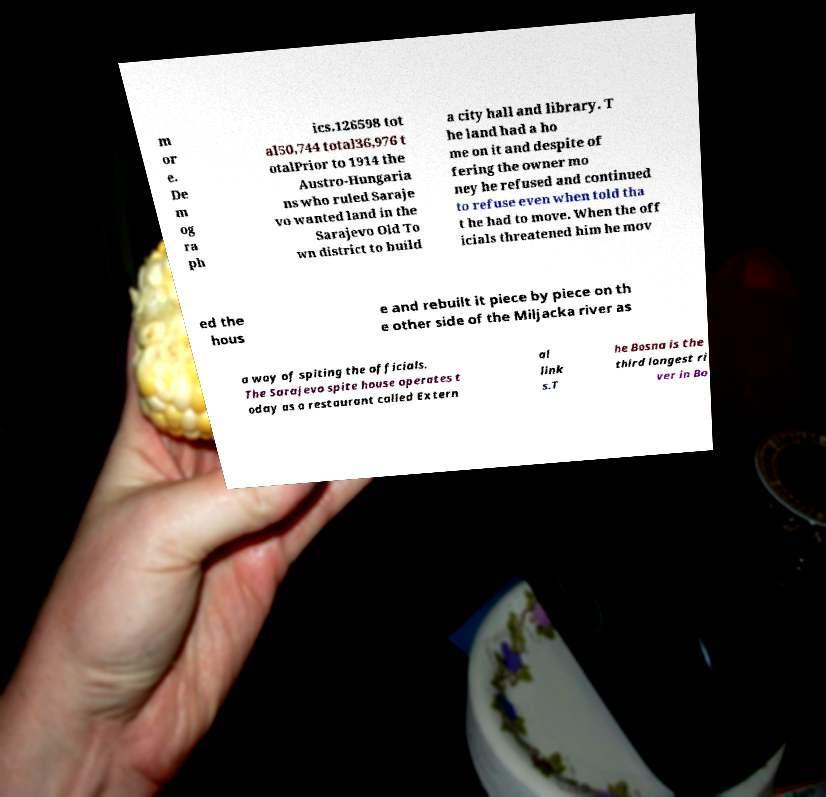Please identify and transcribe the text found in this image. m or e. De m og ra ph ics.126598 tot al50,744 total36,976 t otalPrior to 1914 the Austro-Hungaria ns who ruled Saraje vo wanted land in the Sarajevo Old To wn district to build a city hall and library. T he land had a ho me on it and despite of fering the owner mo ney he refused and continued to refuse even when told tha t he had to move. When the off icials threatened him he mov ed the hous e and rebuilt it piece by piece on th e other side of the Miljacka river as a way of spiting the officials. The Sarajevo spite house operates t oday as a restaurant called Extern al link s.T he Bosna is the third longest ri ver in Bo 